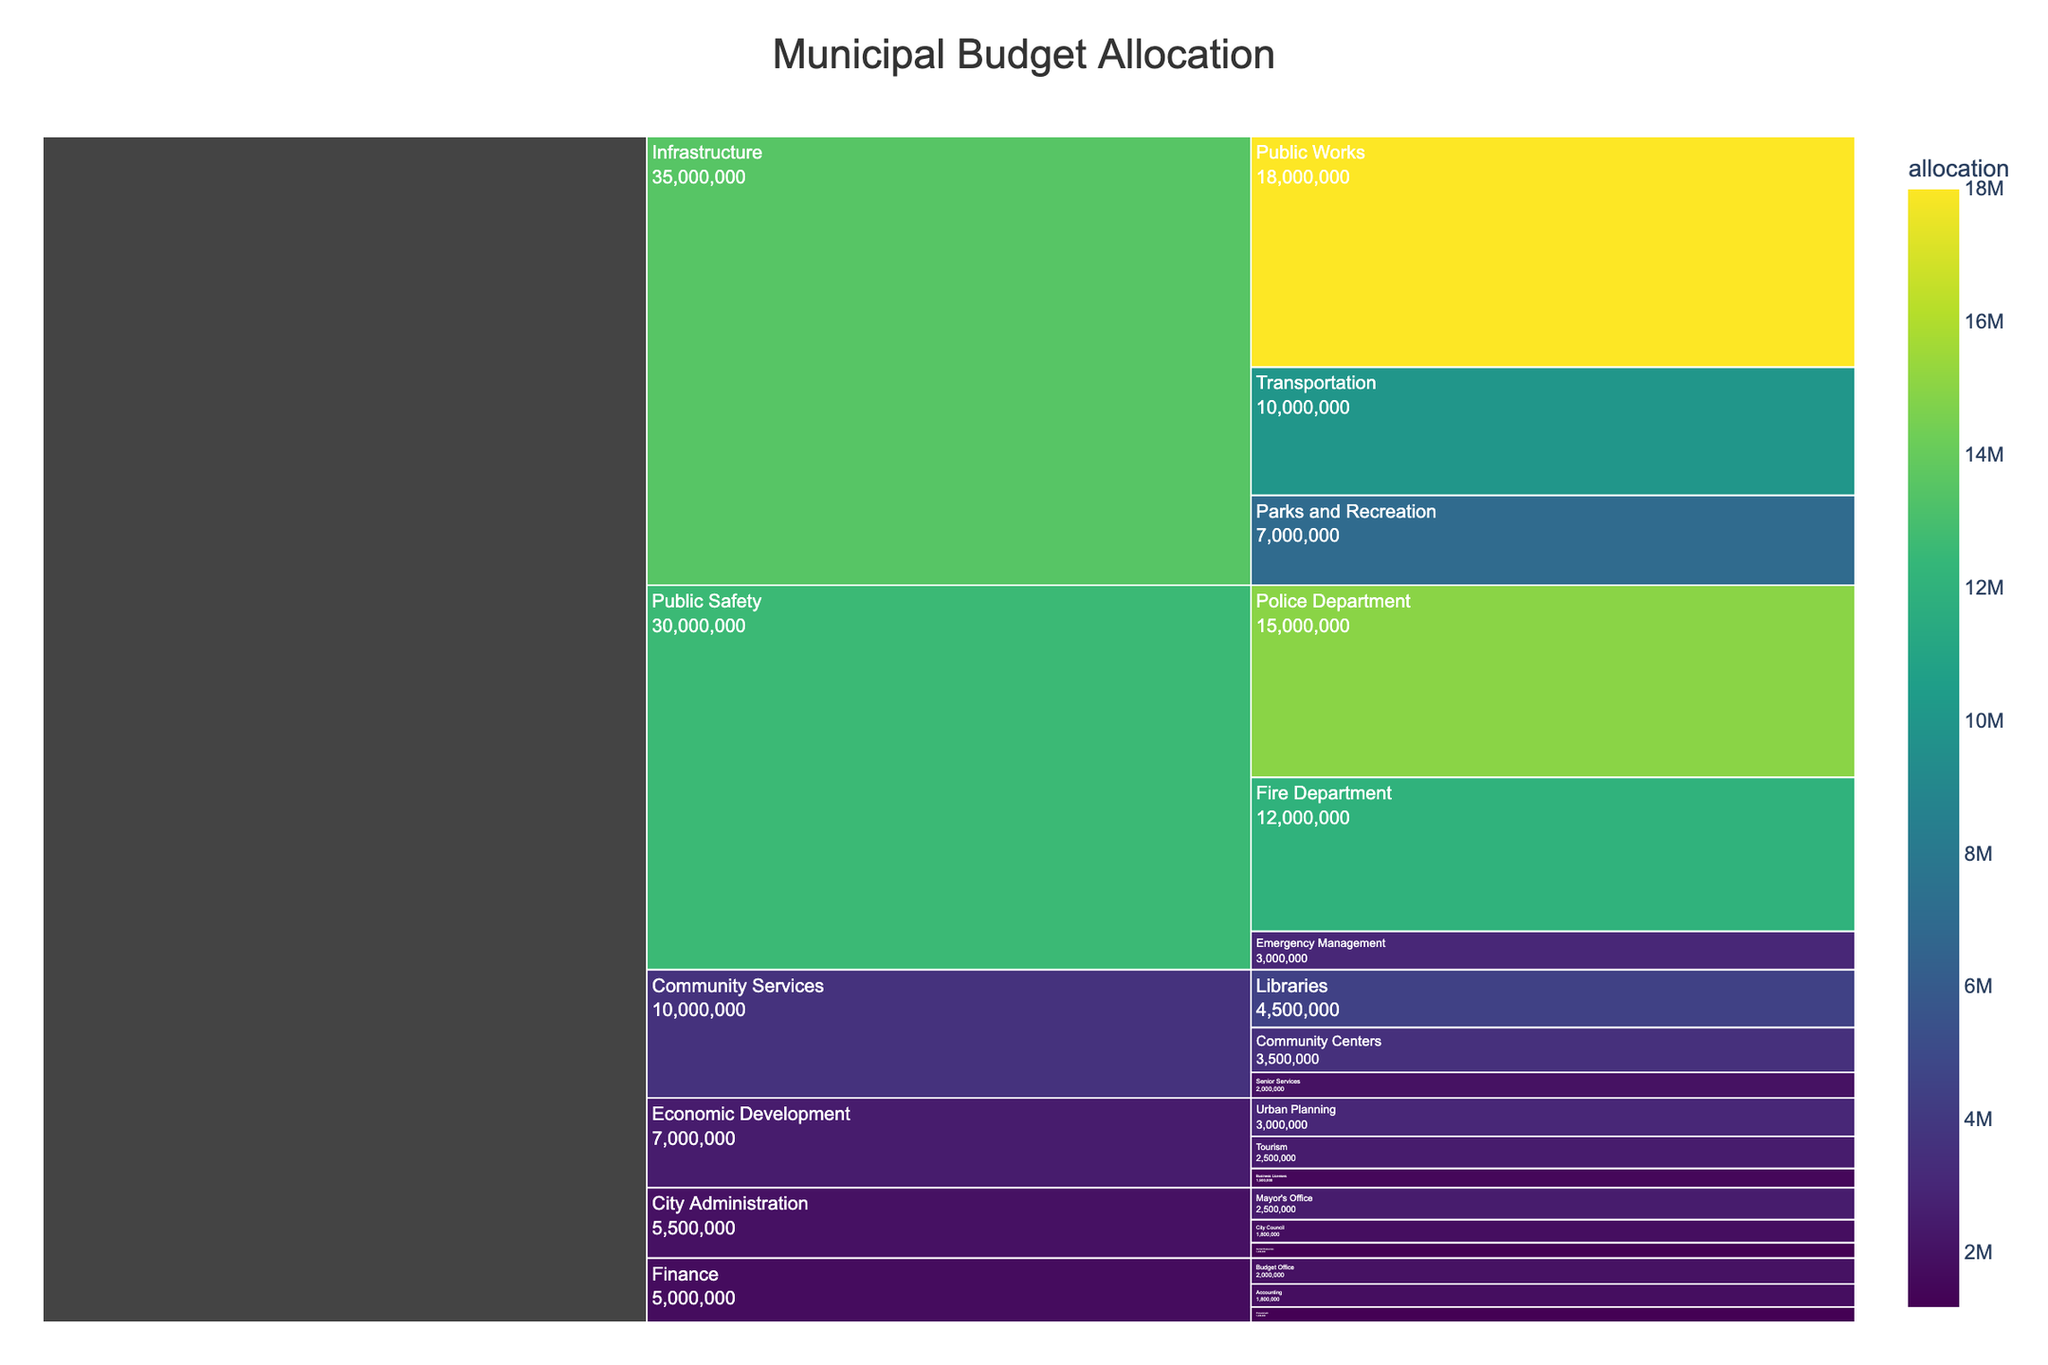What is the title of the Icicle Chart? The title of the chart helps to understand the overall context of the data being represented. In this case, it provides information about the purpose of the visualization.
Answer: Municipal Budget Allocation Which department has the highest total allocation? The departments are represented by the top-level segments in the Icicle Chart, and the one with the largest proportional area or value represents the highest total allocation.
Answer: Infrastructure What is the total allocation for Public Safety? Sum the allocations for all sub-departments within Public Safety: Police Department ($15,000,000), Fire Department ($12,000,000), and Emergency Management ($3,000,000). The total is $15,000,000 + $12,000,000 + $3,000,000 = $30,000,000.
Answer: $30,000,000 Which sub-department in Community Services receives the highest budget? Identify the sub-department within the Community Services segment that has the largest rectangular area.
Answer: Libraries How does the allocation for the Fire Department compare to the Police Department? Check the values for both sub-departments under Public Safety. The Police Department has $15,000,000 and the Fire Department has $12,000,000.
Answer: The Fire Department receives $3,000,000 less than the Police Department What is the combined allocation for Business Licenses and Tourism under Economic Development? Sum the allocations for Business Licenses ($1,500,000) and Tourism ($2,500,000). The total is $1,500,000 + $2,500,000 = $4,000,000.
Answer: $4,000,000 Which department has the smallest total budget? Look at the top-level segments and find the one with the smallest proportional area or value.
Answer: Economic Development What's the difference in allocation between Urban Planning and Procurement? Find the allocations for both sub-departments. Urban Planning has $3,000,000 and Procurement has $1,200,000. The difference is $3,000,000 - $1,200,000 = $1,800,000.
Answer: $1,800,000 What is the total allocation for Community Services? Sum the allocations for Libraries ($4,500,000), Community Centers ($3,500,000), and Senior Services ($2,000,000). The total is $4,500,000 + $3,500,000 + $2,000,000 = $10,000,000.
Answer: $10,000,000 What are the three sub-departments under City Administration, and their respective allocations? Identify the segments under City Administration and note their values.
Answer: Mayor's Office: $2,500,000, City Council: $1,800,000, Human Resources: $1,200,000 